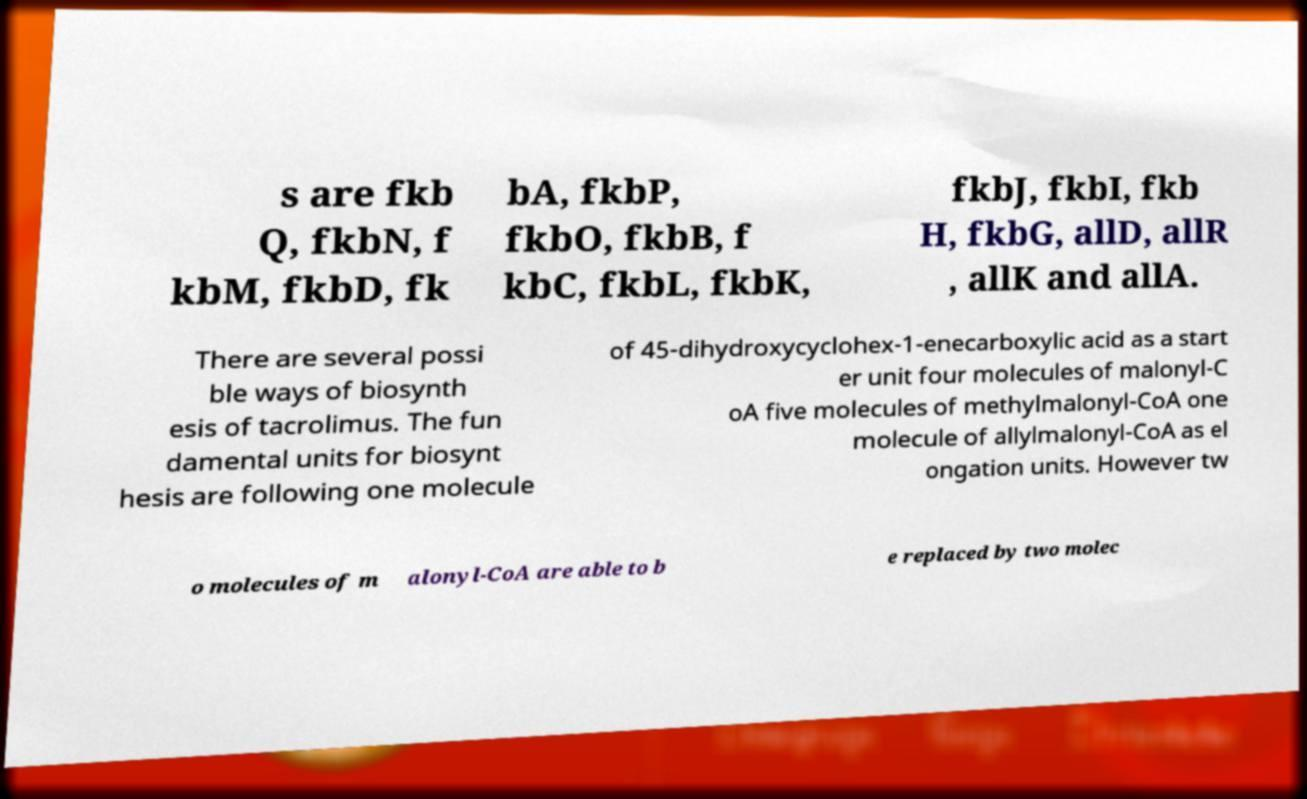Please read and relay the text visible in this image. What does it say? s are fkb Q, fkbN, f kbM, fkbD, fk bA, fkbP, fkbO, fkbB, f kbC, fkbL, fkbK, fkbJ, fkbI, fkb H, fkbG, allD, allR , allK and allA. There are several possi ble ways of biosynth esis of tacrolimus. The fun damental units for biosynt hesis are following one molecule of 45-dihydroxycyclohex-1-enecarboxylic acid as a start er unit four molecules of malonyl-C oA five molecules of methylmalonyl-CoA one molecule of allylmalonyl-CoA as el ongation units. However tw o molecules of m alonyl-CoA are able to b e replaced by two molec 